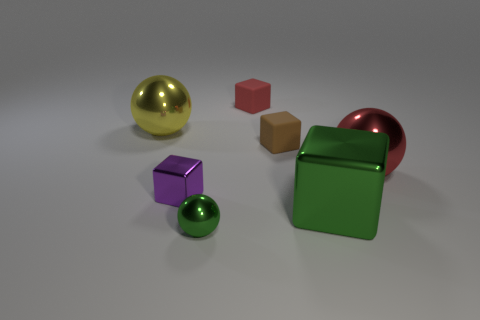There is a matte thing right of the tiny red object; is its color the same as the small metallic ball?
Provide a short and direct response. No. Is there another small metal object of the same shape as the yellow metallic thing?
Offer a terse response. Yes. What is the color of the metal thing that is the same size as the green sphere?
Make the answer very short. Purple. There is a metal cube that is to the left of the tiny metal sphere; what is its size?
Ensure brevity in your answer.  Small. There is a tiny matte thing that is behind the yellow object; are there any small purple things behind it?
Offer a terse response. No. Do the red thing that is to the left of the red metallic ball and the small brown cube have the same material?
Your answer should be very brief. Yes. How many big spheres are behind the brown thing and on the right side of the yellow ball?
Make the answer very short. 0. How many red cubes are made of the same material as the brown thing?
Ensure brevity in your answer.  1. What color is the tiny cube that is made of the same material as the large red object?
Your response must be concise. Purple. Are there fewer purple metal objects than brown metallic spheres?
Make the answer very short. No. 